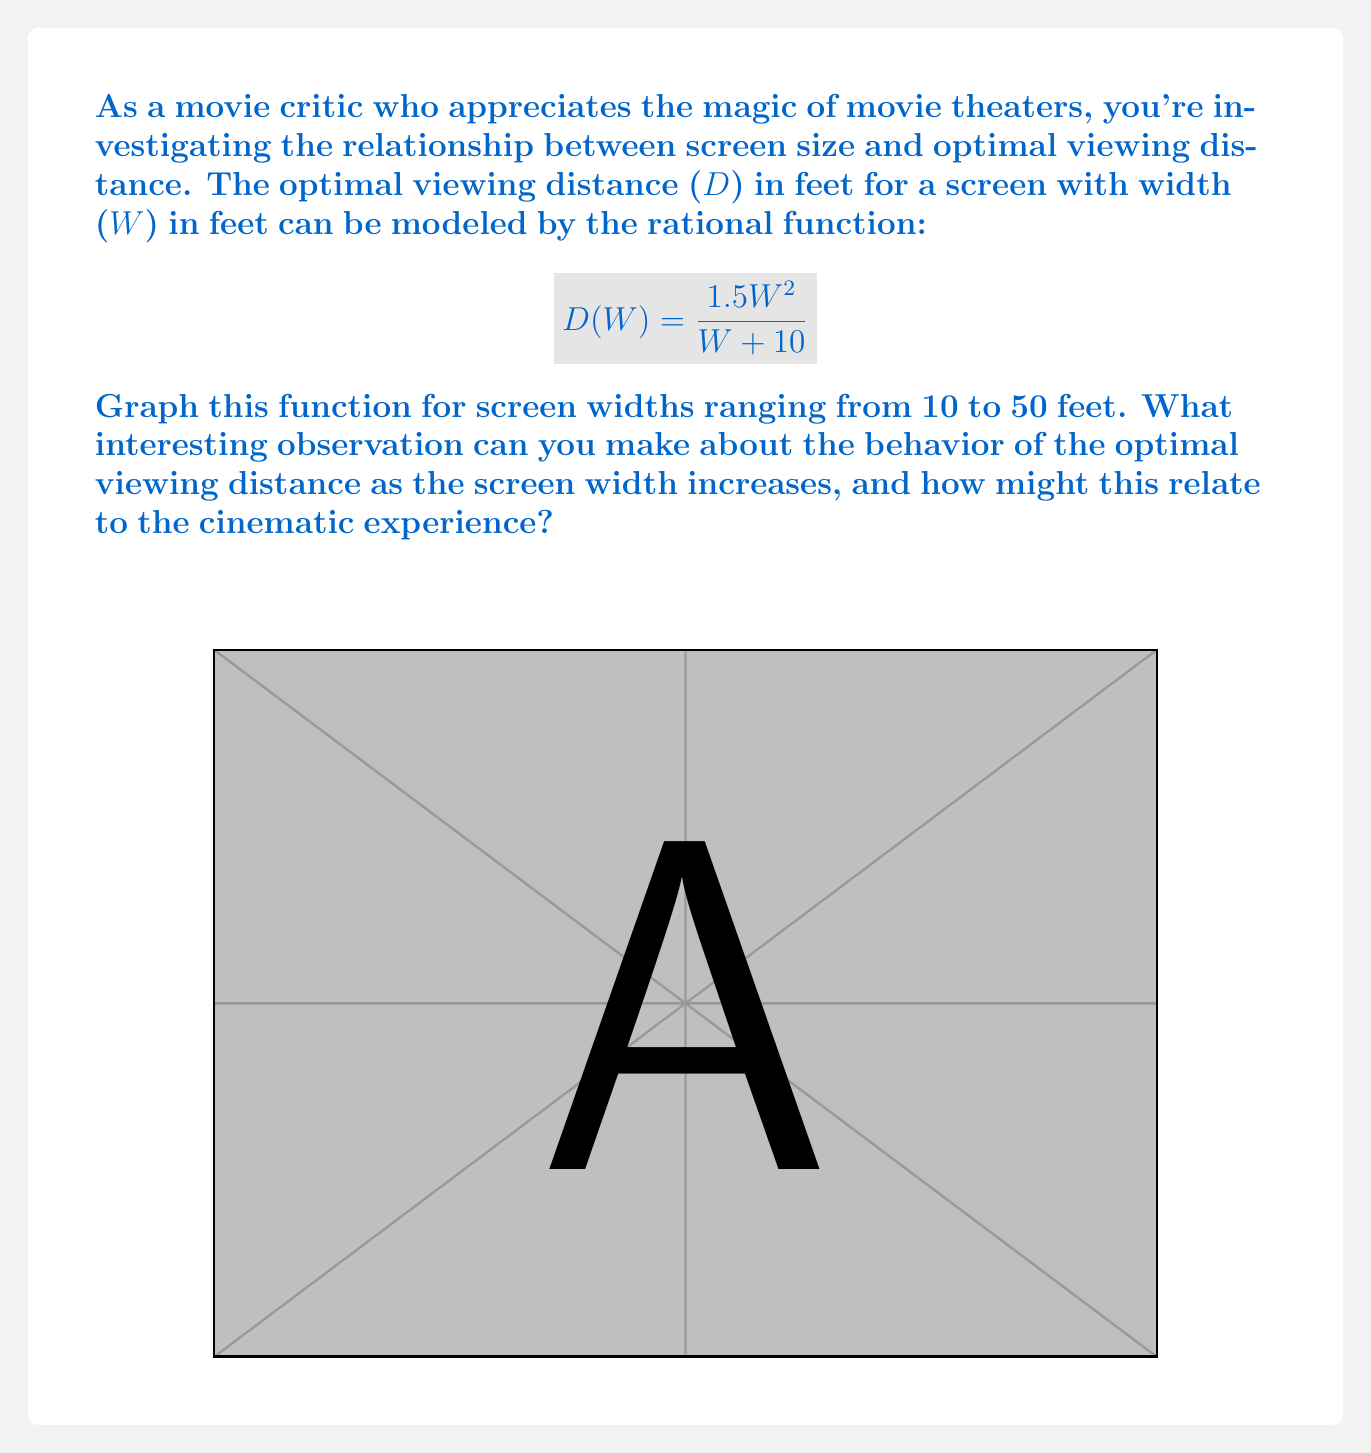Solve this math problem. Let's approach this step-by-step:

1) First, we need to graph the function $D(W) = \frac{1.5W^2}{W + 10}$ for $W$ values from 10 to 50.

2) To understand the behavior, let's calculate some points:
   For $W = 10$: $D(10) = \frac{1.5(10^2)}{10 + 10} = \frac{150}{20} = 7.5$ feet
   For $W = 30$: $D(30) = \frac{1.5(30^2)}{30 + 10} = \frac{1350}{40} = 33.75$ feet
   For $W = 50$: $D(50) = \frac{1.5(50^2)}{50 + 10} = \frac{3750}{60} = 62.5$ feet

3) From the graph and these calculations, we can see that as the screen width increases, the optimal viewing distance also increases, but at a decreasing rate.

4) To understand why this happens, let's look at the limit of the function as W approaches infinity:

   $\lim_{W \to \infty} \frac{1.5W^2}{W + 10} = \lim_{W \to \infty} \frac{1.5W^2}{W(1 + \frac{10}{W})} = \lim_{W \to \infty} \frac{1.5W}{1 + \frac{10}{W}} = 1.5W$

5) This means that for very large screens, the optimal viewing distance approaches 1.5 times the screen width.

6) In terms of the cinematic experience, this suggests that as screens get larger, the rate at which viewers need to move back slows down. This allows theaters to accommodate larger screens without requiring proportionally larger viewing areas, maintaining an immersive experience even with impressive screen sizes.
Answer: As screen width increases, optimal viewing distance grows at a decreasing rate, approaching 1.5 times the screen width for very large screens. 